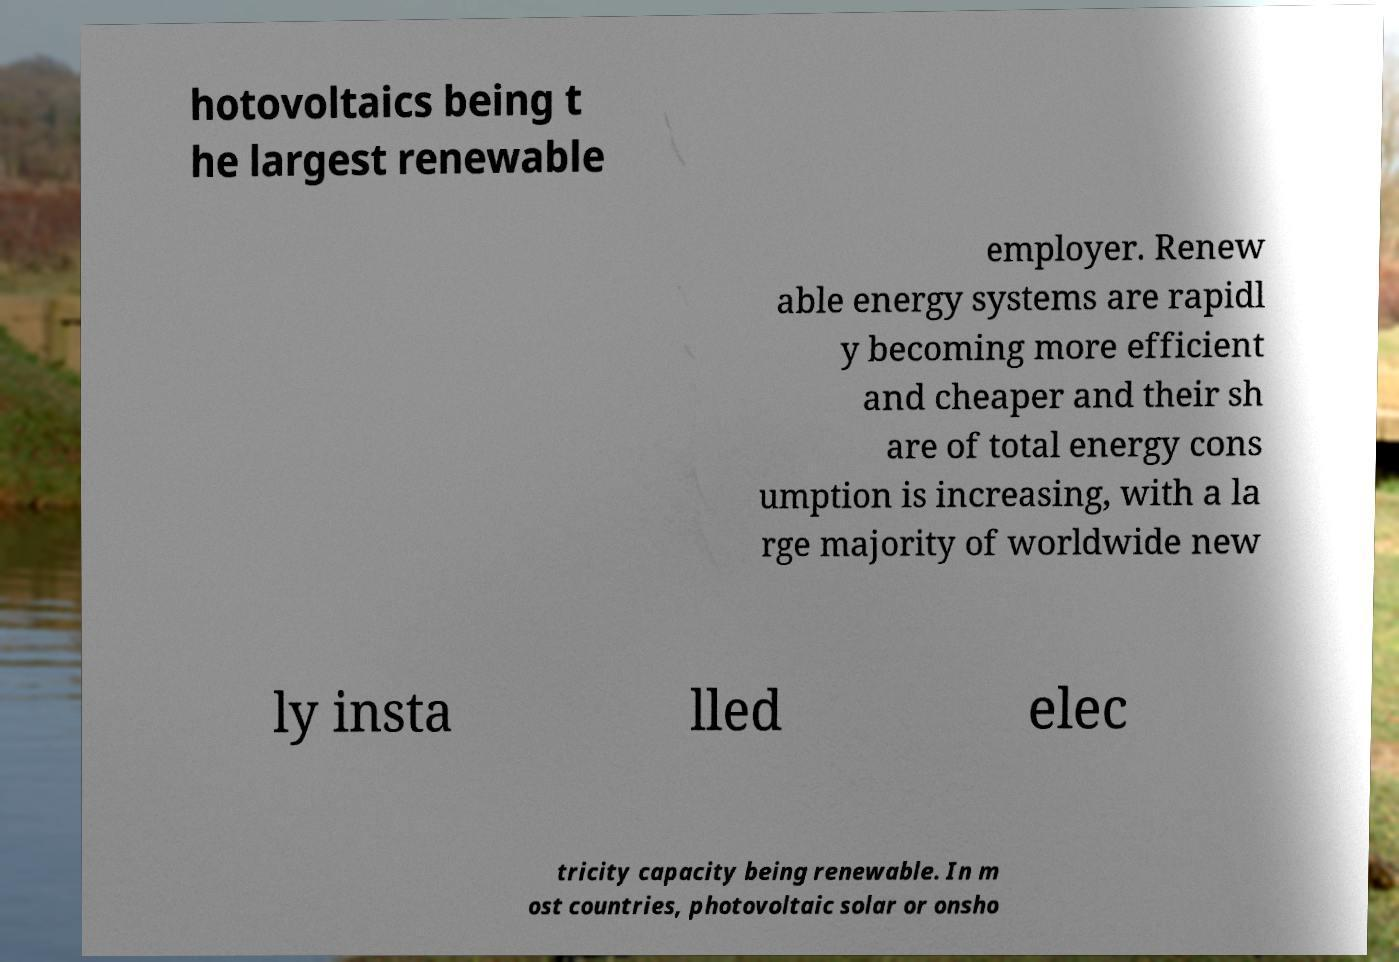Please read and relay the text visible in this image. What does it say? hotovoltaics being t he largest renewable employer. Renew able energy systems are rapidl y becoming more efficient and cheaper and their sh are of total energy cons umption is increasing, with a la rge majority of worldwide new ly insta lled elec tricity capacity being renewable. In m ost countries, photovoltaic solar or onsho 